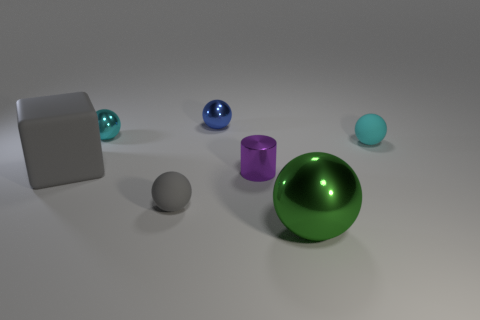What number of other things are the same material as the cylinder?
Keep it short and to the point. 3. What color is the rubber ball that is to the left of the shiny ball in front of the small cyan ball left of the big shiny sphere?
Ensure brevity in your answer.  Gray. There is a gray object that is the same size as the green ball; what material is it?
Give a very brief answer. Rubber. How many things are small rubber balls to the left of the cylinder or small balls?
Give a very brief answer. 4. Are any tiny cyan matte cylinders visible?
Keep it short and to the point. No. There is a big thing that is in front of the big rubber object; what is its material?
Provide a succinct answer. Metal. What number of tiny objects are either purple rubber things or purple metallic cylinders?
Your answer should be very brief. 1. What is the color of the large shiny sphere?
Offer a very short reply. Green. Is there a tiny gray matte thing that is in front of the shiny thing that is in front of the cylinder?
Make the answer very short. No. Are there fewer matte spheres behind the purple cylinder than things?
Your answer should be compact. Yes. 